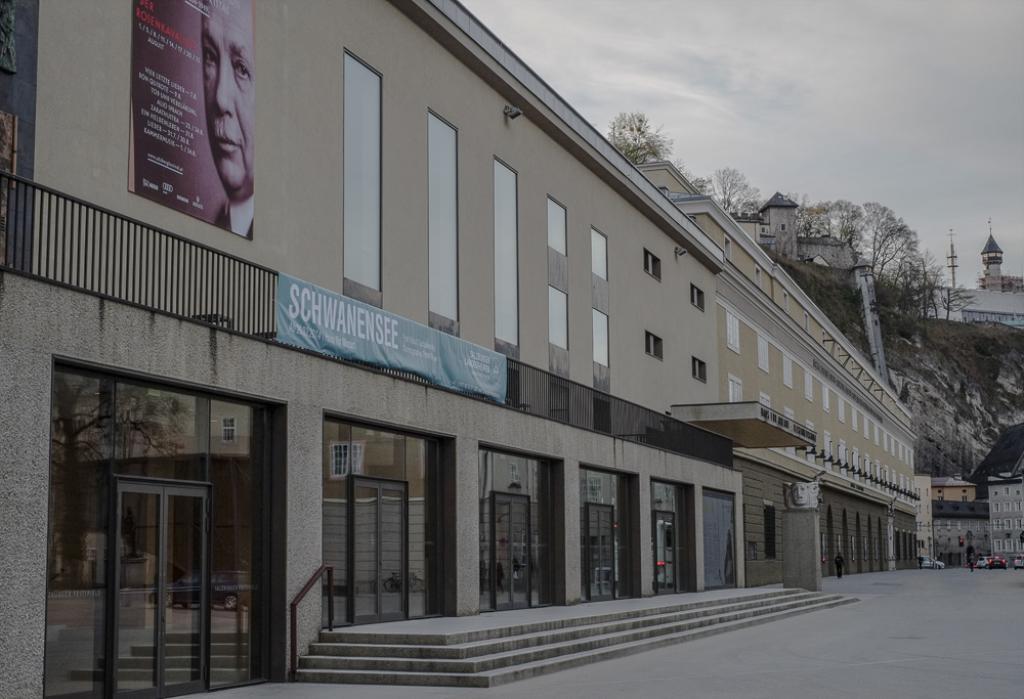Can you describe this image briefly? In this image there is a building with the glass doors in the middle. At the top there is the sky. At the bottom there are steps in front of the building. There is a poster attached to the wall. In the background there are few trees. 